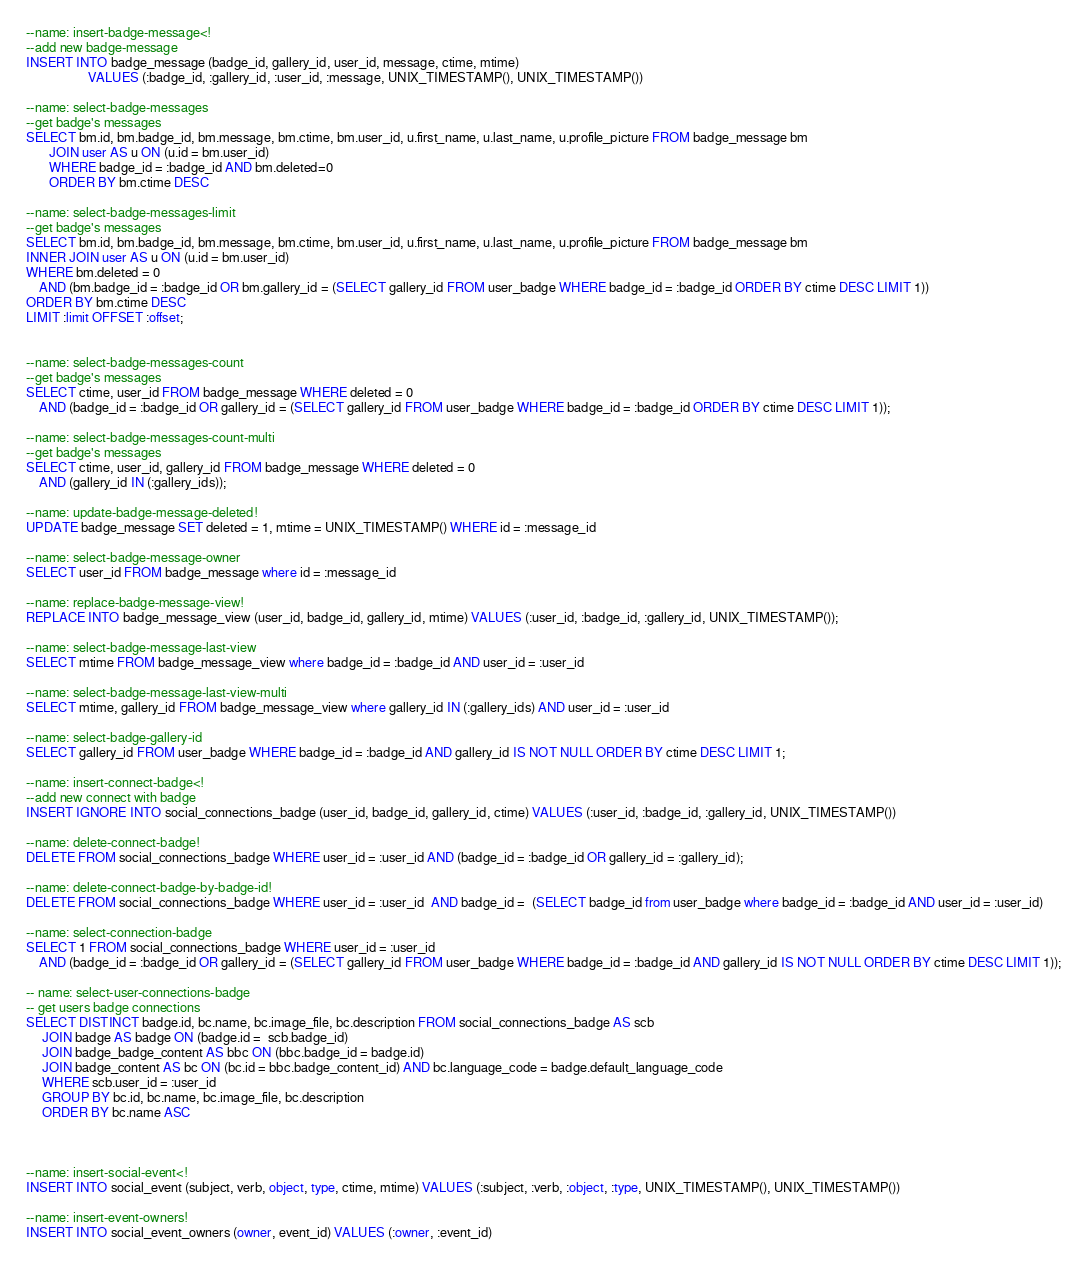<code> <loc_0><loc_0><loc_500><loc_500><_SQL_>--name: insert-badge-message<!
--add new badge-message
INSERT INTO badge_message (badge_id, gallery_id, user_id, message, ctime, mtime)
                   VALUES (:badge_id, :gallery_id, :user_id, :message, UNIX_TIMESTAMP(), UNIX_TIMESTAMP())

--name: select-badge-messages
--get badge's messages
SELECT bm.id, bm.badge_id, bm.message, bm.ctime, bm.user_id, u.first_name, u.last_name, u.profile_picture FROM badge_message bm
       JOIN user AS u ON (u.id = bm.user_id)
       WHERE badge_id = :badge_id AND bm.deleted=0
       ORDER BY bm.ctime DESC

--name: select-badge-messages-limit
--get badge's messages
SELECT bm.id, bm.badge_id, bm.message, bm.ctime, bm.user_id, u.first_name, u.last_name, u.profile_picture FROM badge_message bm
INNER JOIN user AS u ON (u.id = bm.user_id)
WHERE bm.deleted = 0
    AND (bm.badge_id = :badge_id OR bm.gallery_id = (SELECT gallery_id FROM user_badge WHERE badge_id = :badge_id ORDER BY ctime DESC LIMIT 1))
ORDER BY bm.ctime DESC
LIMIT :limit OFFSET :offset;


--name: select-badge-messages-count
--get badge's messages
SELECT ctime, user_id FROM badge_message WHERE deleted = 0
    AND (badge_id = :badge_id OR gallery_id = (SELECT gallery_id FROM user_badge WHERE badge_id = :badge_id ORDER BY ctime DESC LIMIT 1));

--name: select-badge-messages-count-multi
--get badge's messages
SELECT ctime, user_id, gallery_id FROM badge_message WHERE deleted = 0
    AND (gallery_id IN (:gallery_ids));

--name: update-badge-message-deleted!
UPDATE badge_message SET deleted = 1, mtime = UNIX_TIMESTAMP() WHERE id = :message_id

--name: select-badge-message-owner
SELECT user_id FROM badge_message where id = :message_id

--name: replace-badge-message-view!
REPLACE INTO badge_message_view (user_id, badge_id, gallery_id, mtime) VALUES (:user_id, :badge_id, :gallery_id, UNIX_TIMESTAMP());

--name: select-badge-message-last-view
SELECT mtime FROM badge_message_view where badge_id = :badge_id AND user_id = :user_id

--name: select-badge-message-last-view-multi
SELECT mtime, gallery_id FROM badge_message_view where gallery_id IN (:gallery_ids) AND user_id = :user_id

--name: select-badge-gallery-id
SELECT gallery_id FROM user_badge WHERE badge_id = :badge_id AND gallery_id IS NOT NULL ORDER BY ctime DESC LIMIT 1;

--name: insert-connect-badge<!
--add new connect with badge
INSERT IGNORE INTO social_connections_badge (user_id, badge_id, gallery_id, ctime) VALUES (:user_id, :badge_id, :gallery_id, UNIX_TIMESTAMP())

--name: delete-connect-badge!
DELETE FROM social_connections_badge WHERE user_id = :user_id AND (badge_id = :badge_id OR gallery_id = :gallery_id);

--name: delete-connect-badge-by-badge-id!
DELETE FROM social_connections_badge WHERE user_id = :user_id  AND badge_id =  (SELECT badge_id from user_badge where badge_id = :badge_id AND user_id = :user_id)

--name: select-connection-badge
SELECT 1 FROM social_connections_badge WHERE user_id = :user_id
    AND (badge_id = :badge_id OR gallery_id = (SELECT gallery_id FROM user_badge WHERE badge_id = :badge_id AND gallery_id IS NOT NULL ORDER BY ctime DESC LIMIT 1));

-- name: select-user-connections-badge
-- get users badge connections
SELECT DISTINCT badge.id, bc.name, bc.image_file, bc.description FROM social_connections_badge AS scb
     JOIN badge AS badge ON (badge.id =  scb.badge_id)
     JOIN badge_badge_content AS bbc ON (bbc.badge_id = badge.id)
     JOIN badge_content AS bc ON (bc.id = bbc.badge_content_id) AND bc.language_code = badge.default_language_code
     WHERE scb.user_id = :user_id
     GROUP BY bc.id, bc.name, bc.image_file, bc.description
     ORDER BY bc.name ASC



--name: insert-social-event<!
INSERT INTO social_event (subject, verb, object, type, ctime, mtime) VALUES (:subject, :verb, :object, :type, UNIX_TIMESTAMP(), UNIX_TIMESTAMP())

--name: insert-event-owners!
INSERT INTO social_event_owners (owner, event_id) VALUES (:owner, :event_id)

</code> 